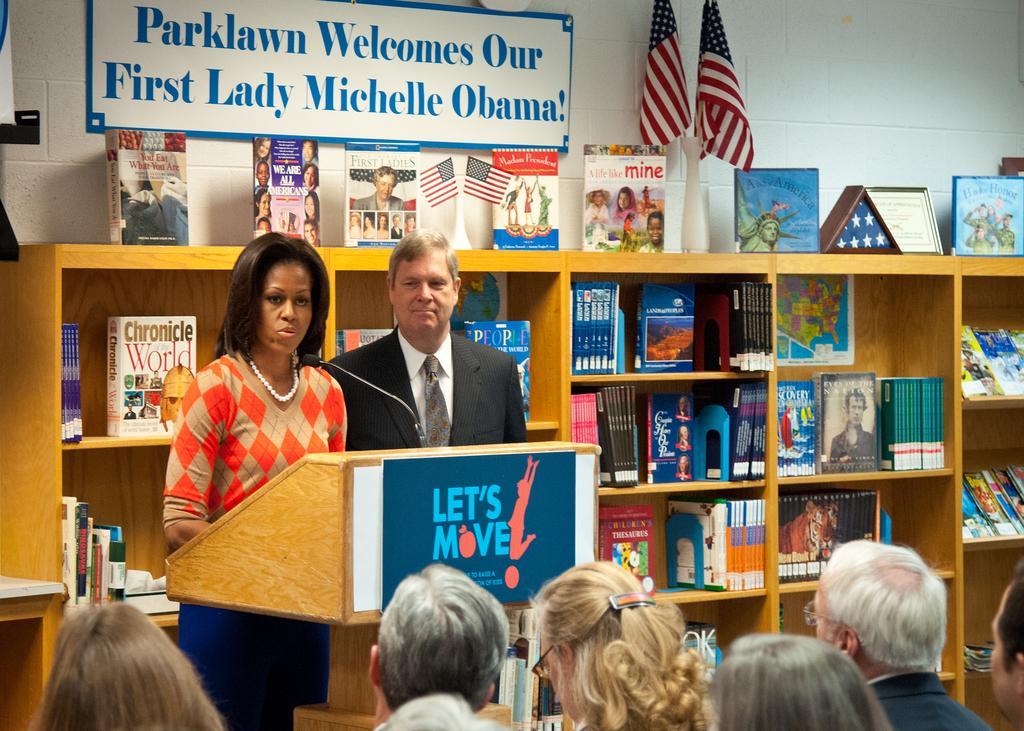How would you summarize this image in a sentence or two? In this image I can see at the bottom few people are there, in the middle a woman is standing near the podium and speaking in the microphone, beside her there is a man. He is wearing tie, shirt, coat. In the background there are books on the shelves. At the top there are flags. 